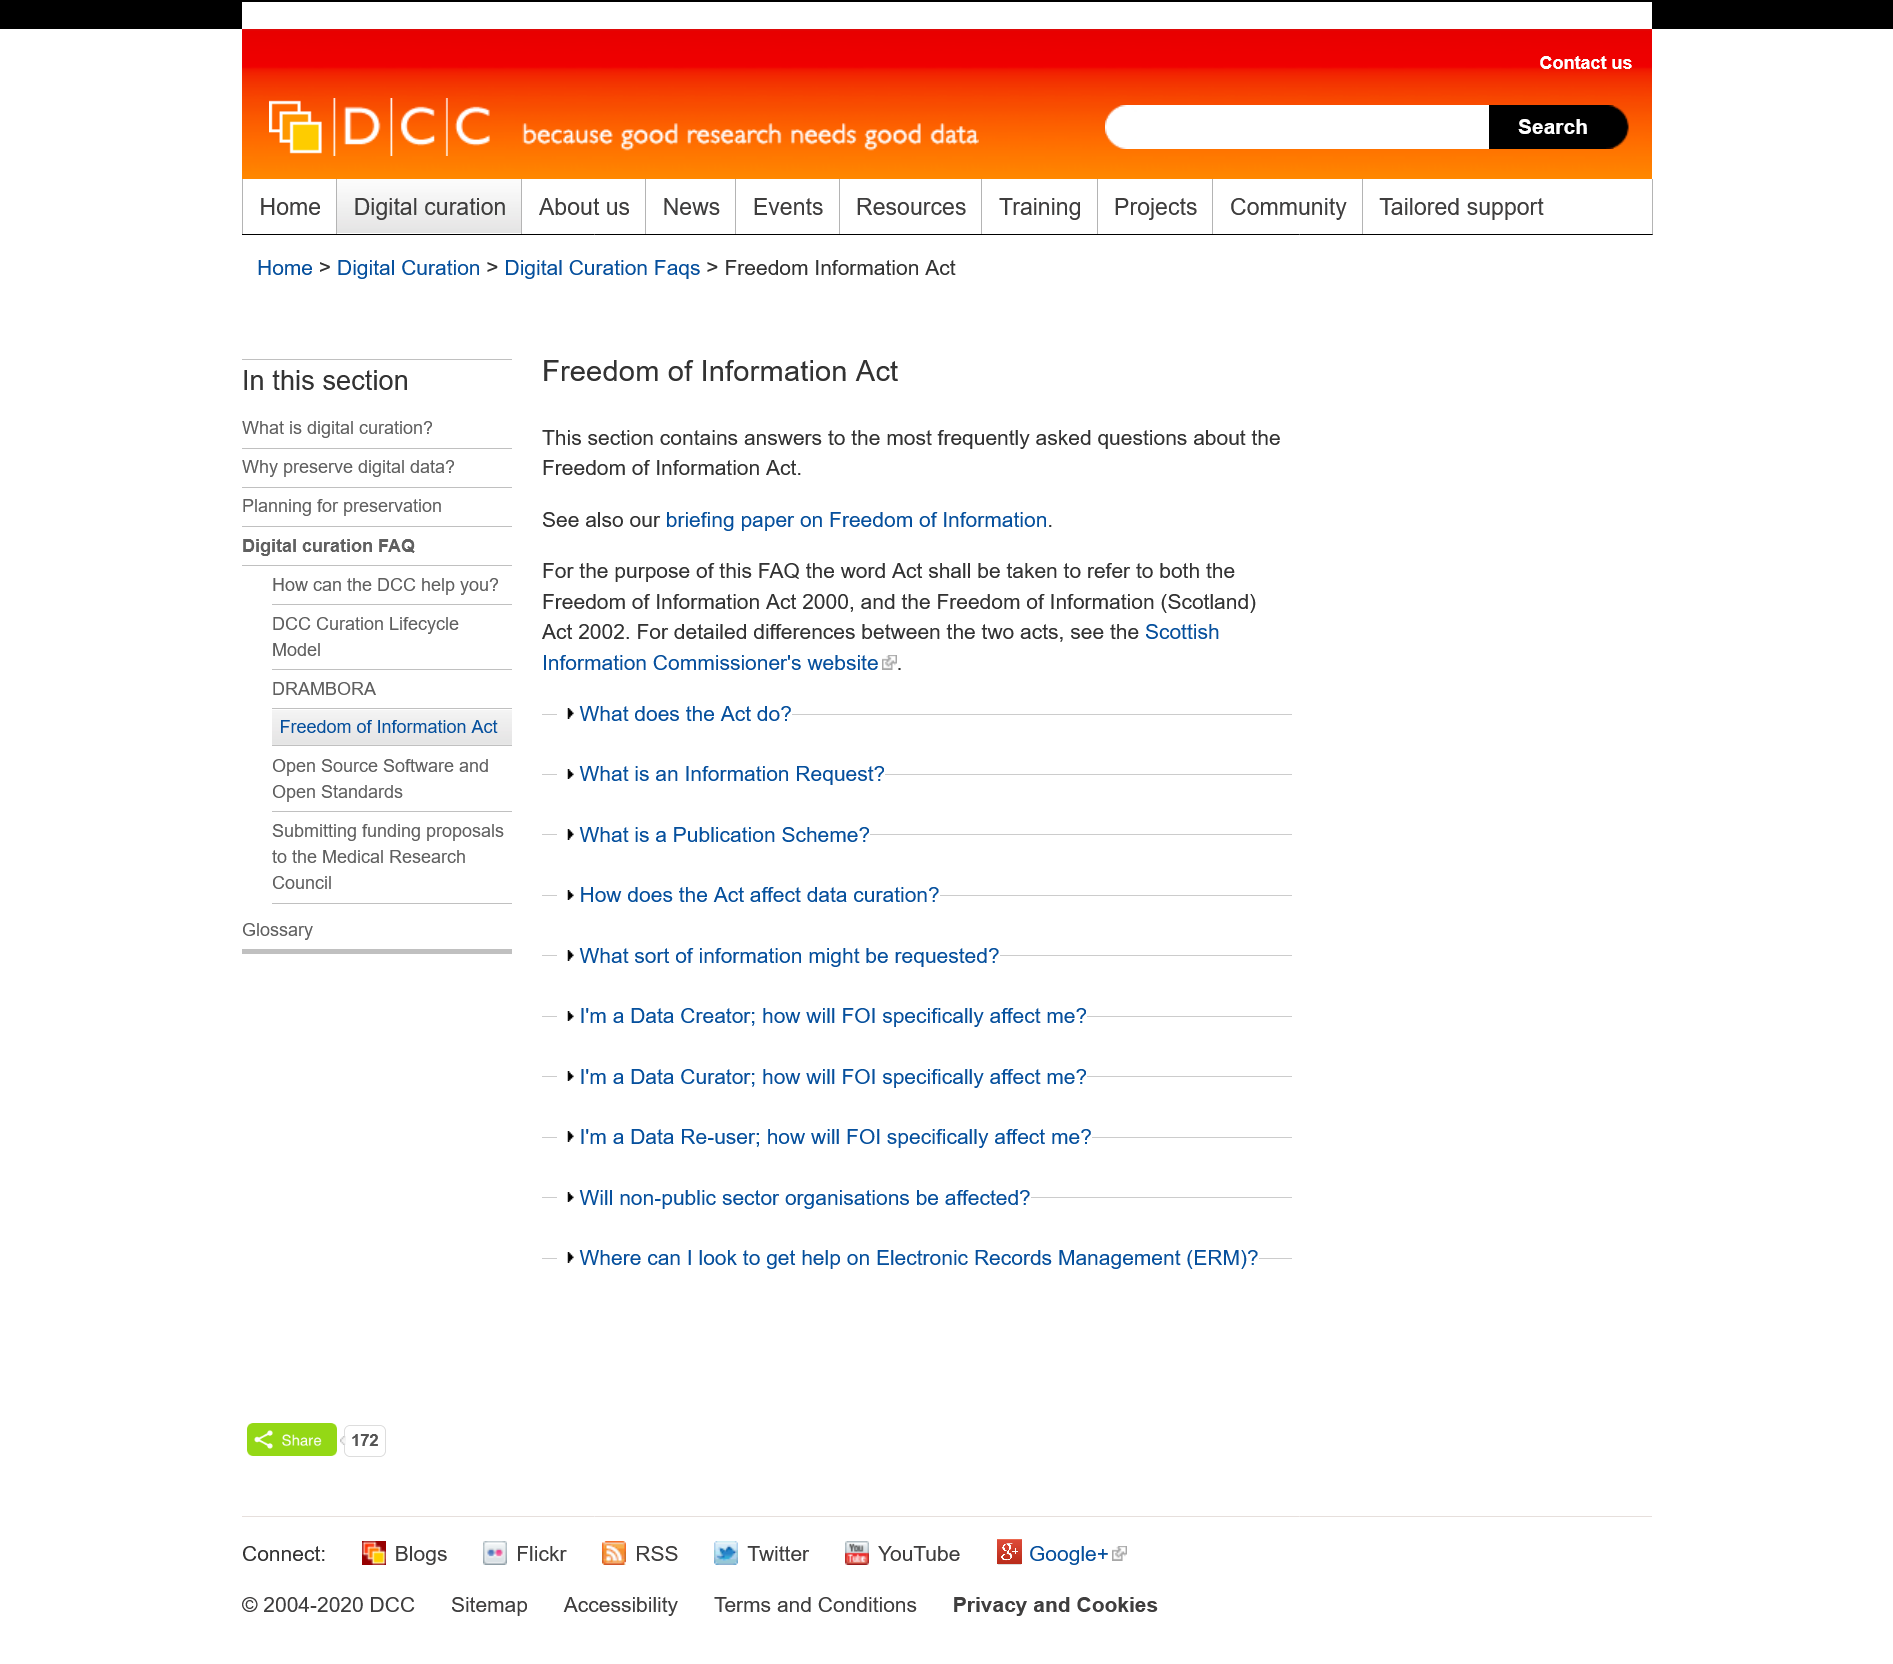Highlight a few significant elements in this photo. Yes, the FAQ refers to more than one act. The Freedom of Information Act 2000 and the Freedom of Information (Scotland) Act 2002 can be found on the Scottish Information Commissioner's website, where the detailed differences between the two are clearly outlined. The briefing paper on Freedom of Information is referred to in the FAQ for the Freedom of Information Act and is a part of the Freedom of Information Act. 